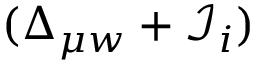Convert formula to latex. <formula><loc_0><loc_0><loc_500><loc_500>( \Delta _ { \mu w } + \mathcal { I } _ { i } )</formula> 